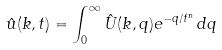Convert formula to latex. <formula><loc_0><loc_0><loc_500><loc_500>\hat { u } ( k , t ) = \int _ { 0 } ^ { \infty } \hat { U } ( k , q ) e ^ { - q / t ^ { n } } \, d q</formula> 